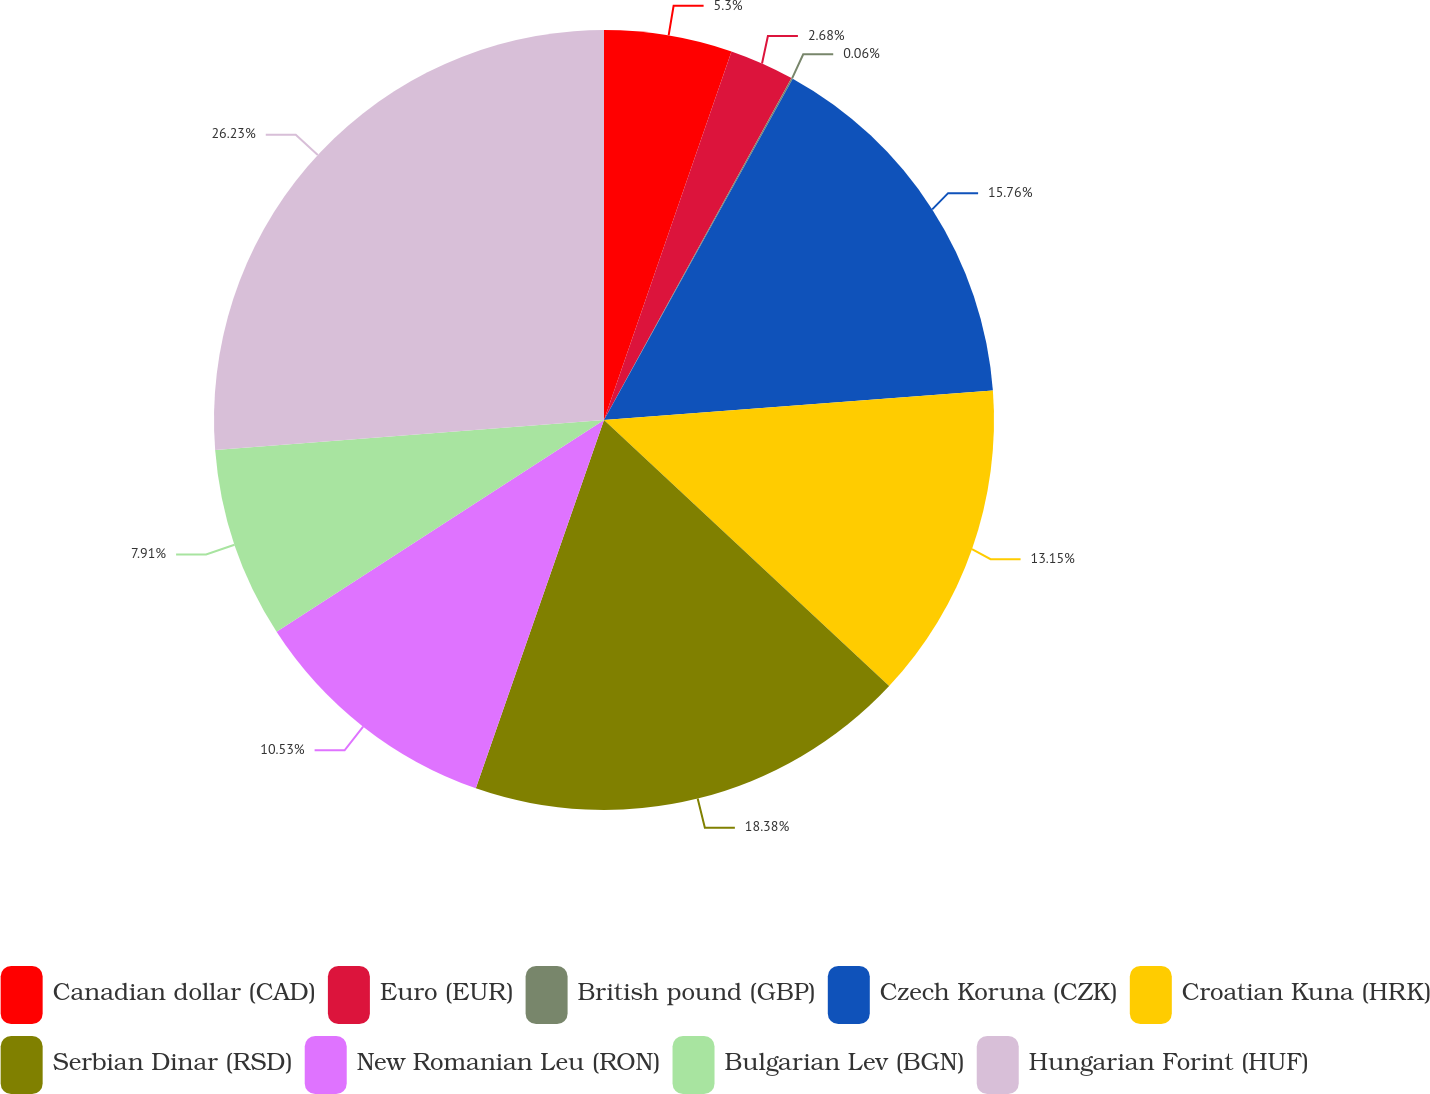Convert chart. <chart><loc_0><loc_0><loc_500><loc_500><pie_chart><fcel>Canadian dollar (CAD)<fcel>Euro (EUR)<fcel>British pound (GBP)<fcel>Czech Koruna (CZK)<fcel>Croatian Kuna (HRK)<fcel>Serbian Dinar (RSD)<fcel>New Romanian Leu (RON)<fcel>Bulgarian Lev (BGN)<fcel>Hungarian Forint (HUF)<nl><fcel>5.3%<fcel>2.68%<fcel>0.06%<fcel>15.76%<fcel>13.15%<fcel>18.38%<fcel>10.53%<fcel>7.91%<fcel>26.23%<nl></chart> 